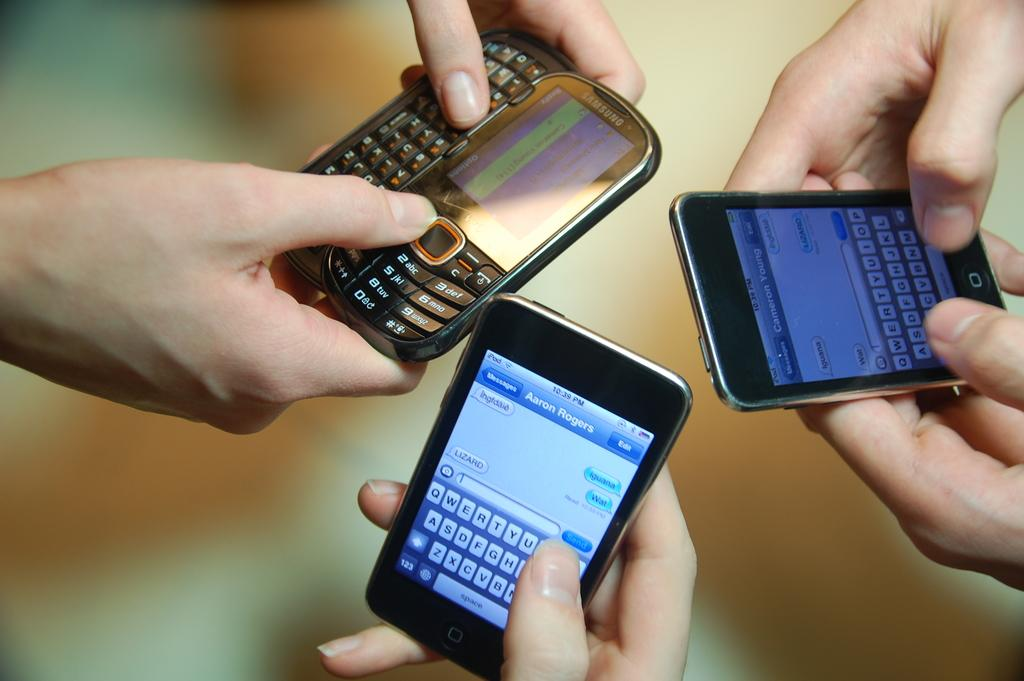What can be seen in the hands of the persons in the image? The persons are holding mobiles in their hands. What is the condition of the background in the image? The background of the image is blurred. What type of curve can be seen in the image? There is no curve visible in the image. How many quinces are present in the image? There are no quinces present in the image. 